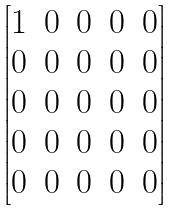<formula> <loc_0><loc_0><loc_500><loc_500>\begin{bmatrix} 1 & 0 & 0 & 0 & 0 \\ 0 & 0 & 0 & 0 & 0 \\ 0 & 0 & 0 & 0 & 0 \\ 0 & 0 & 0 & 0 & 0 \\ 0 & 0 & 0 & 0 & 0 \end{bmatrix}</formula> 